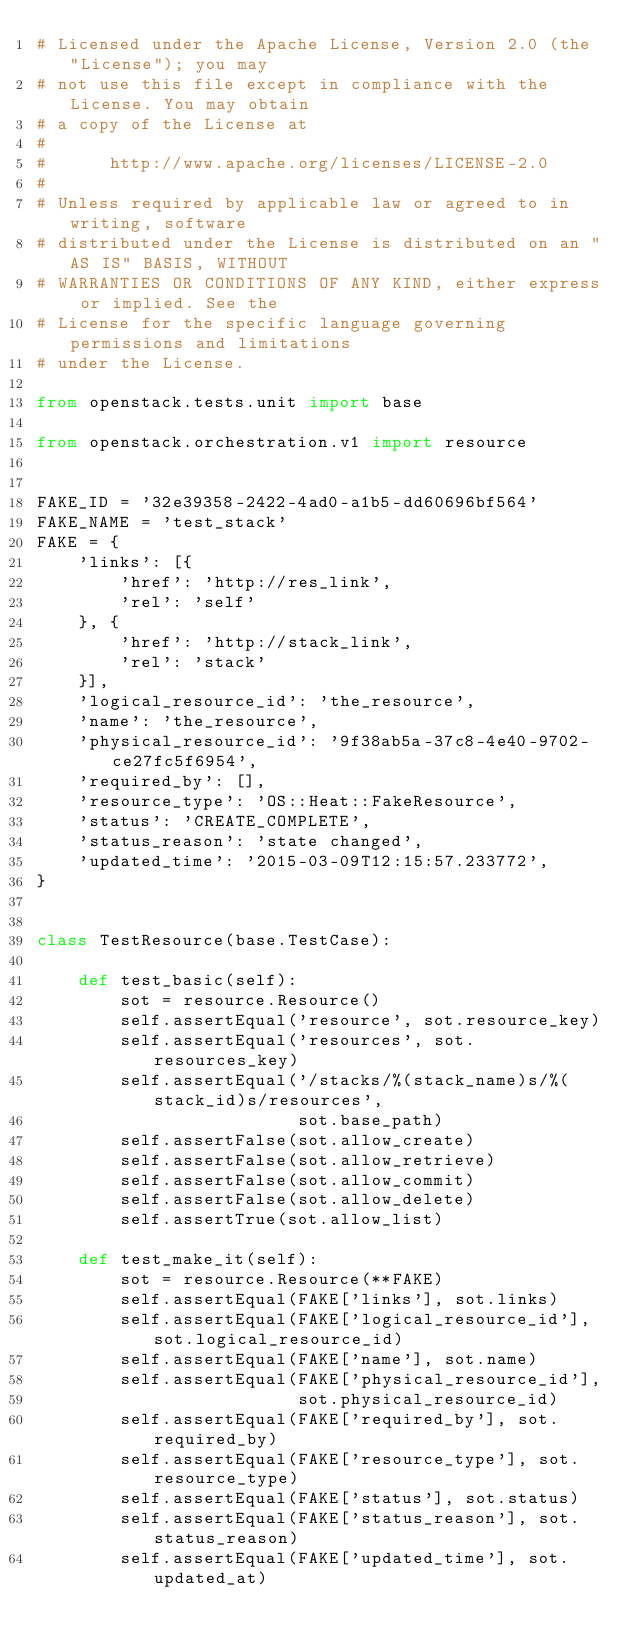<code> <loc_0><loc_0><loc_500><loc_500><_Python_># Licensed under the Apache License, Version 2.0 (the "License"); you may
# not use this file except in compliance with the License. You may obtain
# a copy of the License at
#
#      http://www.apache.org/licenses/LICENSE-2.0
#
# Unless required by applicable law or agreed to in writing, software
# distributed under the License is distributed on an "AS IS" BASIS, WITHOUT
# WARRANTIES OR CONDITIONS OF ANY KIND, either express or implied. See the
# License for the specific language governing permissions and limitations
# under the License.

from openstack.tests.unit import base

from openstack.orchestration.v1 import resource


FAKE_ID = '32e39358-2422-4ad0-a1b5-dd60696bf564'
FAKE_NAME = 'test_stack'
FAKE = {
    'links': [{
        'href': 'http://res_link',
        'rel': 'self'
    }, {
        'href': 'http://stack_link',
        'rel': 'stack'
    }],
    'logical_resource_id': 'the_resource',
    'name': 'the_resource',
    'physical_resource_id': '9f38ab5a-37c8-4e40-9702-ce27fc5f6954',
    'required_by': [],
    'resource_type': 'OS::Heat::FakeResource',
    'status': 'CREATE_COMPLETE',
    'status_reason': 'state changed',
    'updated_time': '2015-03-09T12:15:57.233772',
}


class TestResource(base.TestCase):

    def test_basic(self):
        sot = resource.Resource()
        self.assertEqual('resource', sot.resource_key)
        self.assertEqual('resources', sot.resources_key)
        self.assertEqual('/stacks/%(stack_name)s/%(stack_id)s/resources',
                         sot.base_path)
        self.assertFalse(sot.allow_create)
        self.assertFalse(sot.allow_retrieve)
        self.assertFalse(sot.allow_commit)
        self.assertFalse(sot.allow_delete)
        self.assertTrue(sot.allow_list)

    def test_make_it(self):
        sot = resource.Resource(**FAKE)
        self.assertEqual(FAKE['links'], sot.links)
        self.assertEqual(FAKE['logical_resource_id'], sot.logical_resource_id)
        self.assertEqual(FAKE['name'], sot.name)
        self.assertEqual(FAKE['physical_resource_id'],
                         sot.physical_resource_id)
        self.assertEqual(FAKE['required_by'], sot.required_by)
        self.assertEqual(FAKE['resource_type'], sot.resource_type)
        self.assertEqual(FAKE['status'], sot.status)
        self.assertEqual(FAKE['status_reason'], sot.status_reason)
        self.assertEqual(FAKE['updated_time'], sot.updated_at)
</code> 